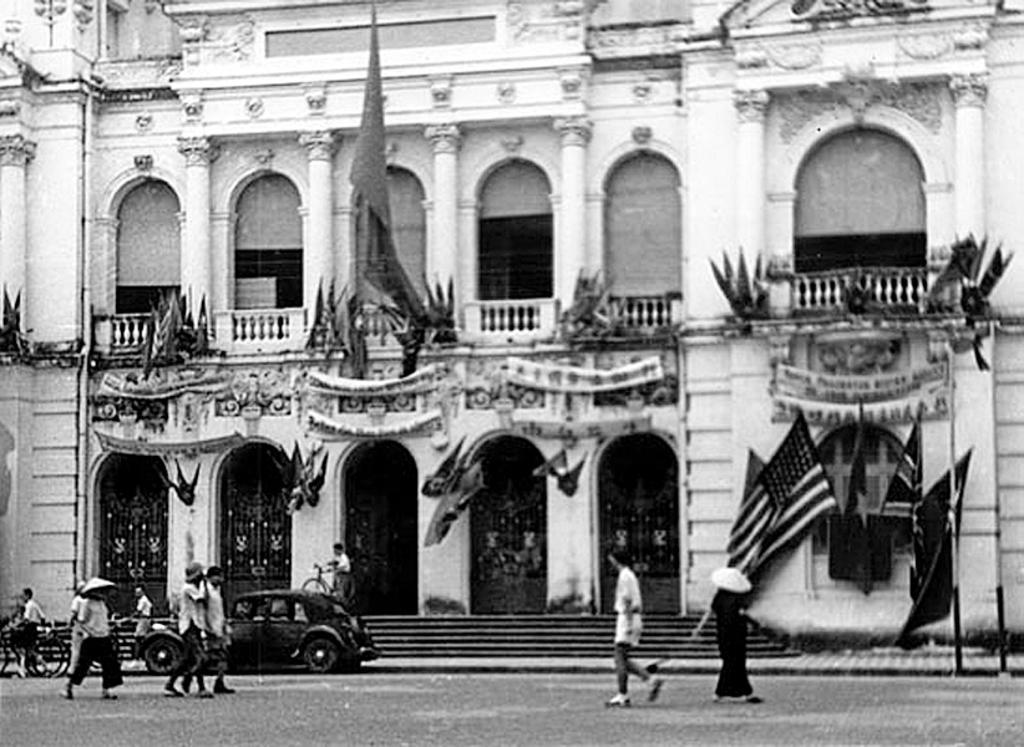Could you give a brief overview of what you see in this image? It is a black and white picture. In this picture I can see a building, flags, people, steps, vehicles and objects. 